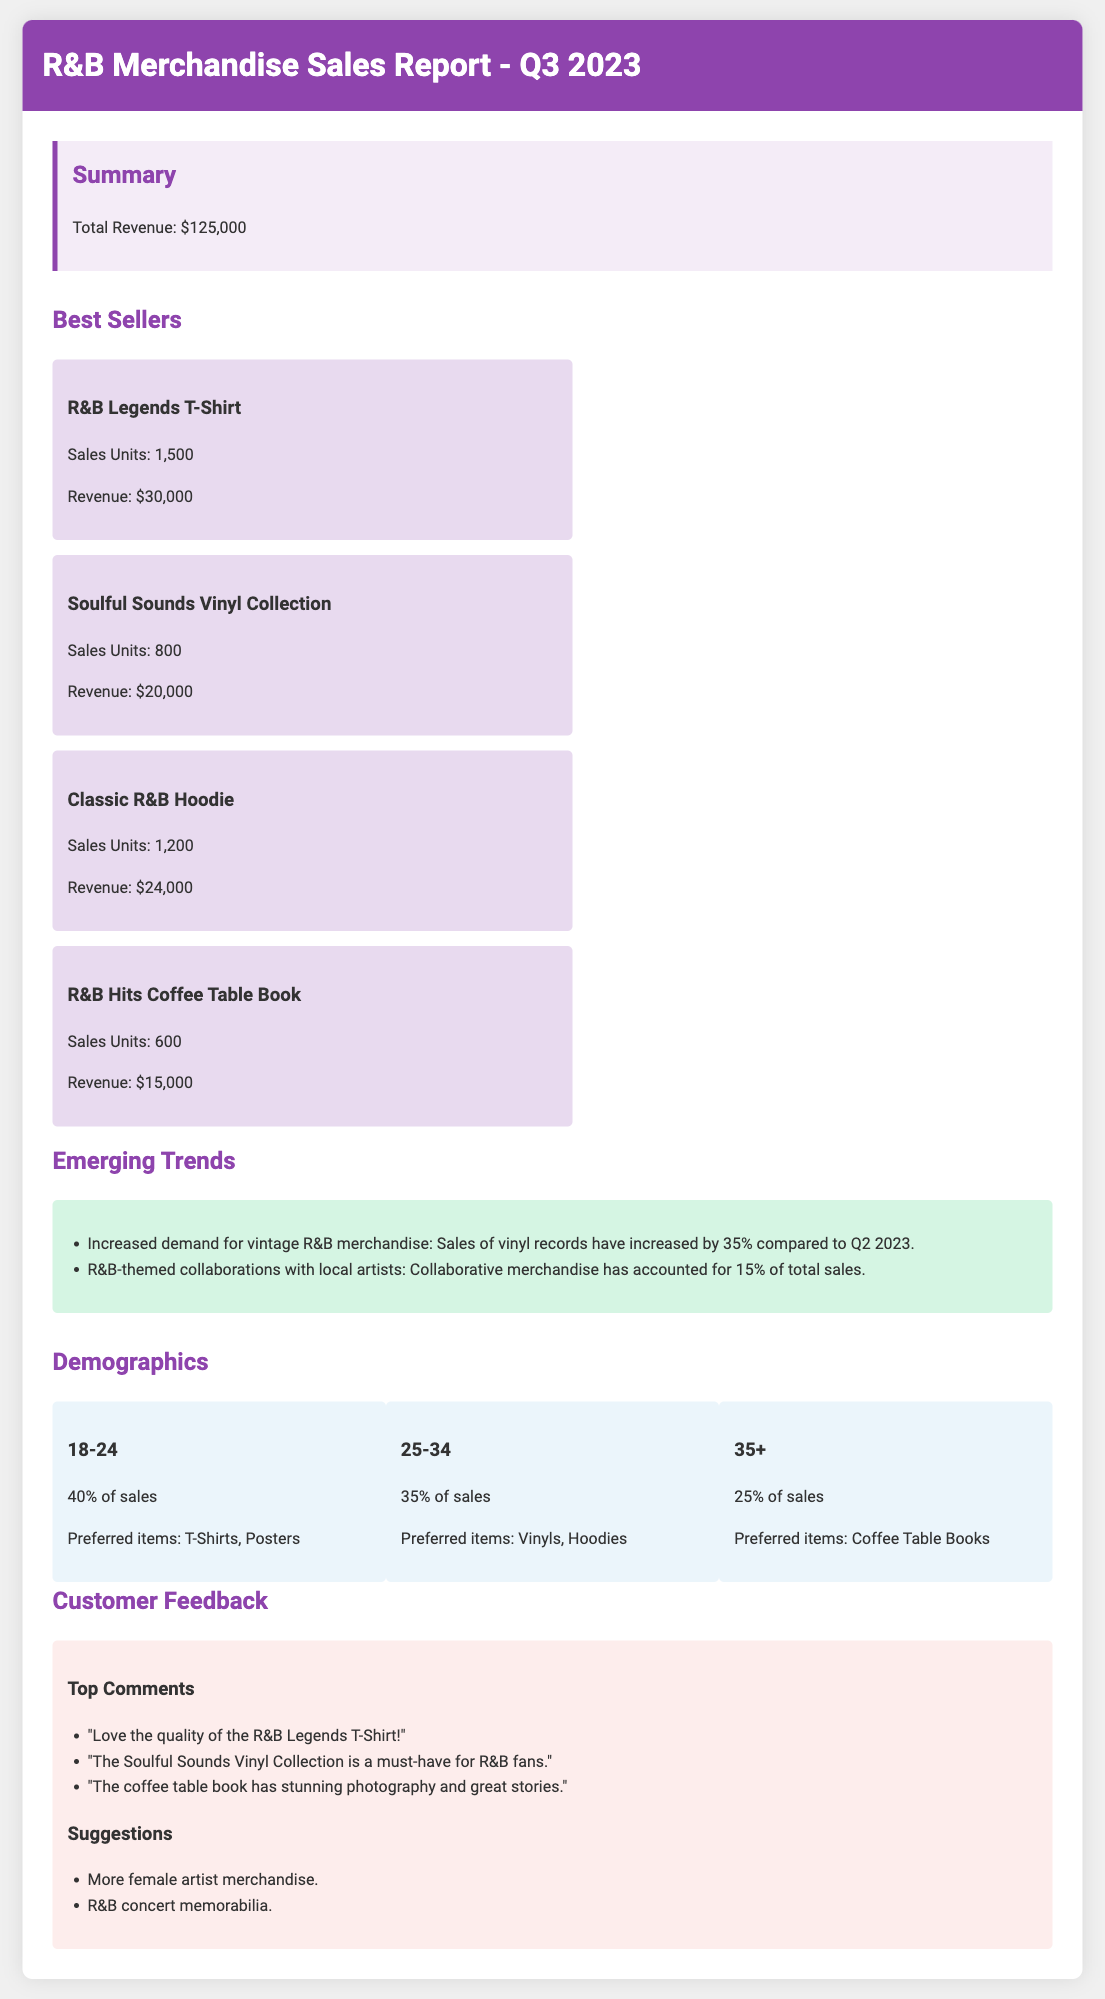What is the total revenue? The total revenue is explicitly stated in the summary section of the document.
Answer: $125,000 What is the best-selling merchandise item? The best-selling item is highlighted in the best sellers section, being the one with the highest sales units.
Answer: R&B Legends T-Shirt How many units of the Classic R&B Hoodie were sold? The number of sales units for the Classic R&B Hoodie is provided in the best sellers section.
Answer: 1,200 What percentage of sales came from the 18-24 age group? The percentage of sales for each age group is listed in the demographics section.
Answer: 40% What is the revenue from the Soulful Sounds Vinyl Collection? The revenue for each best-selling item is included in the best sellers section, specifying the Soulful Sounds Vinyl Collection.
Answer: $20,000 By what percentage did vinyl record sales increase compared to Q2 2023? This percentage is mentioned in the trends section, noting the increase from the previous quarter.
Answer: 35% Which age group prefers T-Shirts and Posters? The preferred items for each age group are outlined in the demographics section, indicating preferences.
Answer: 18-24 What is one suggestion made by customers? Customer suggestions are listed in the feedback section, indicating what customers want to see more of.
Answer: More female artist merchandise 